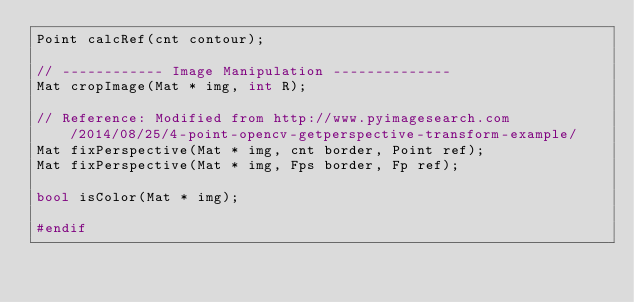Convert code to text. <code><loc_0><loc_0><loc_500><loc_500><_C++_>Point calcRef(cnt contour);

// ------------ Image Manipulation --------------
Mat cropImage(Mat * img, int R);

// Reference: Modified from http://www.pyimagesearch.com/2014/08/25/4-point-opencv-getperspective-transform-example/
Mat fixPerspective(Mat * img, cnt border, Point ref);
Mat fixPerspective(Mat * img, Fps border, Fp ref);

bool isColor(Mat * img);

#endif
</code> 